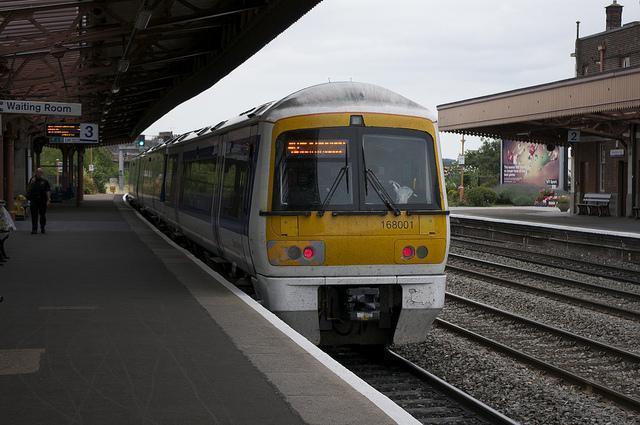How many tracks are to the right of the train?
Give a very brief answer. 3. 